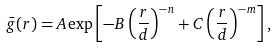Convert formula to latex. <formula><loc_0><loc_0><loc_500><loc_500>\bar { g } ( r ) = A \exp \left [ - B \left ( \frac { r } { d } \right ) ^ { - n } + C \left ( \frac { r } { d } \right ) ^ { - m } \right ] ,</formula> 